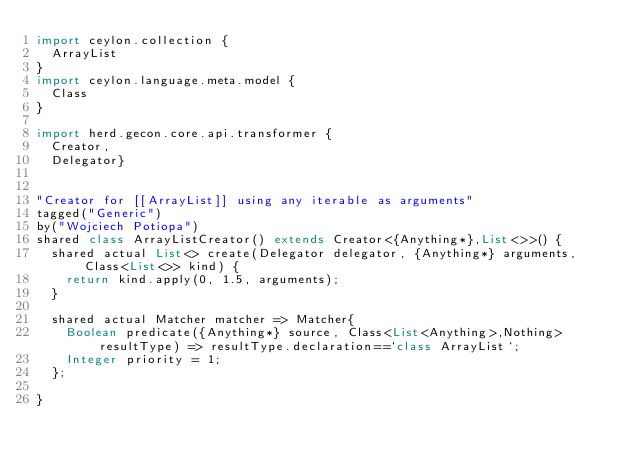<code> <loc_0><loc_0><loc_500><loc_500><_Ceylon_>import ceylon.collection {
	ArrayList
}
import ceylon.language.meta.model {
	Class
}

import herd.gecon.core.api.transformer {
	Creator,
	Delegator}


"Creator for [[ArrayList]] using any iterable as arguments"
tagged("Generic")
by("Wojciech Potiopa")
shared class ArrayListCreator() extends Creator<{Anything*},List<>>() {
	shared actual List<> create(Delegator delegator, {Anything*} arguments,Class<List<>> kind) {
		return kind.apply(0, 1.5, arguments);
	}
	
	shared actual Matcher matcher => Matcher{
		Boolean predicate({Anything*} source, Class<List<Anything>,Nothing> resultType) => resultType.declaration==`class ArrayList`;
		Integer priority = 1;
	};
	
}

</code> 